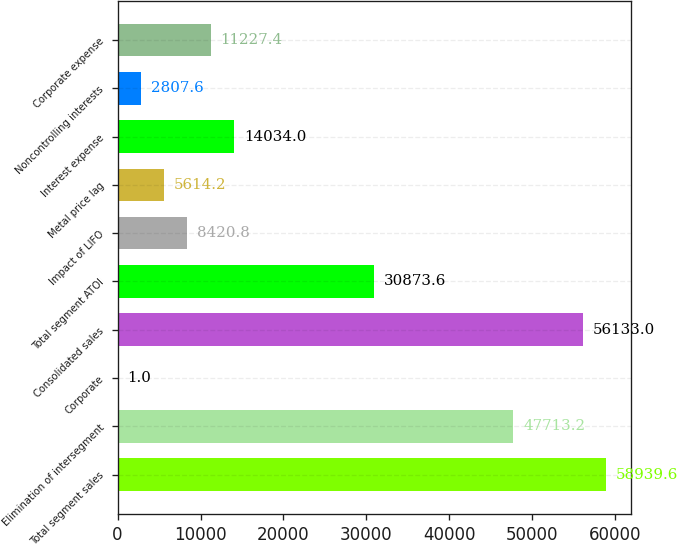<chart> <loc_0><loc_0><loc_500><loc_500><bar_chart><fcel>Total segment sales<fcel>Elimination of intersegment<fcel>Corporate<fcel>Consolidated sales<fcel>Total segment ATOI<fcel>Impact of LIFO<fcel>Metal price lag<fcel>Interest expense<fcel>Noncontrolling interests<fcel>Corporate expense<nl><fcel>58939.6<fcel>47713.2<fcel>1<fcel>56133<fcel>30873.6<fcel>8420.8<fcel>5614.2<fcel>14034<fcel>2807.6<fcel>11227.4<nl></chart> 